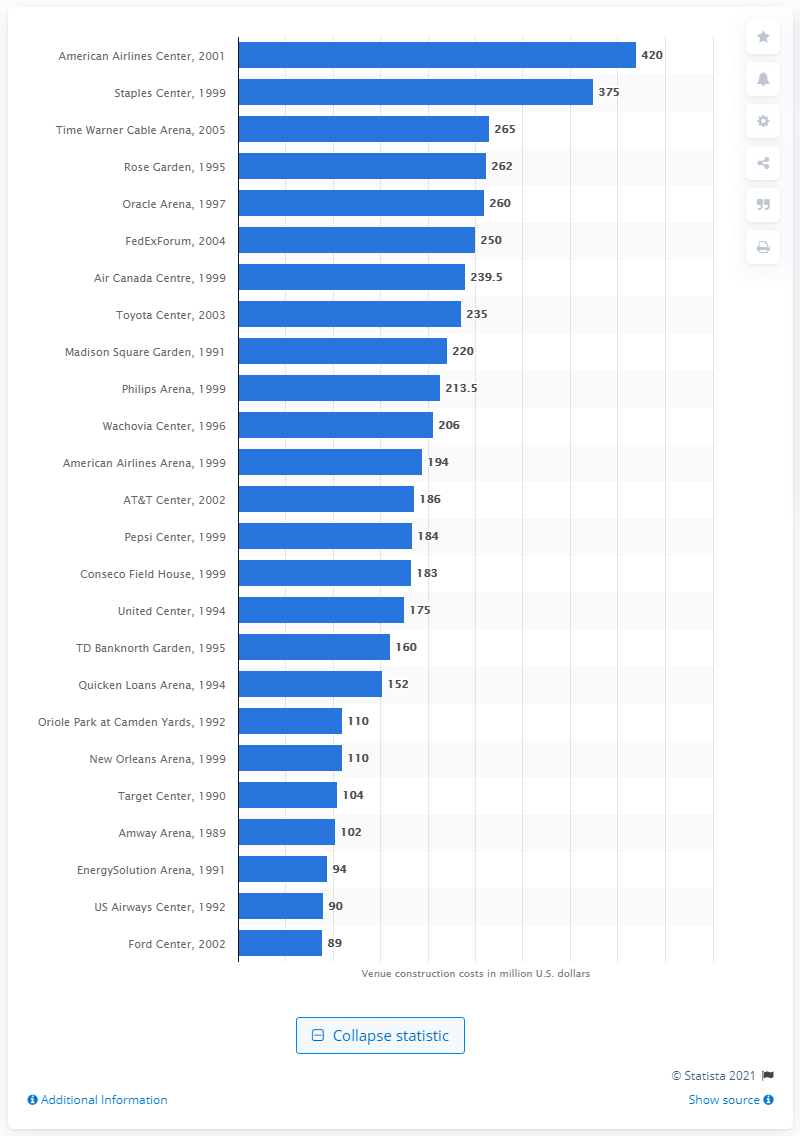Indicate a few pertinent items in this graphic. The construction of the Quicken Loans Arena cost $152 million in 1994. 